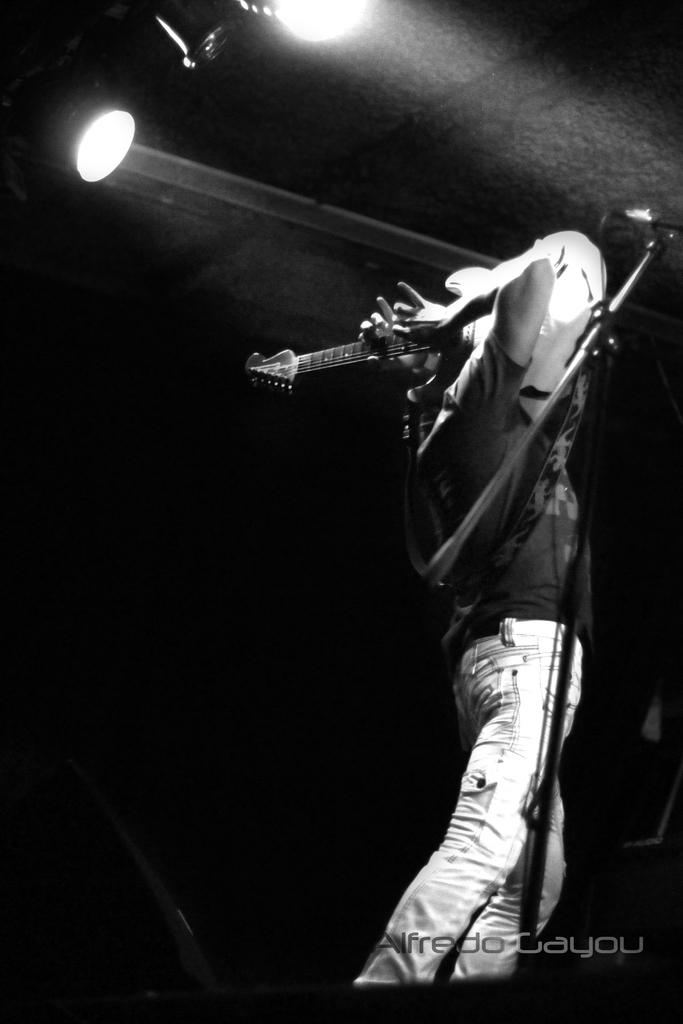What is the main subject of the image? There is a person in the image. What is the person doing in the image? The person is standing and playing a musical instrument. What can be seen in the background of the image? There are lights visible in the background of the image. What type of zipper can be seen on the person's clothing in the image? There is no zipper visible on the person's clothing in the image. Is there a beggar present in the image? There is no mention of a beggar in the image, and the main subject is a person playing a musical instrument. 